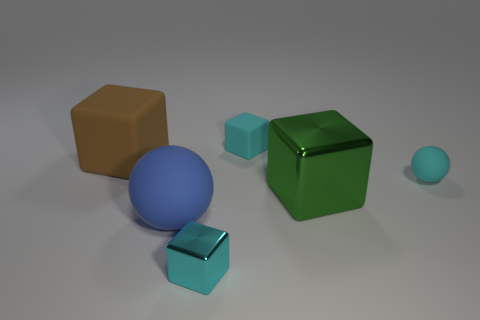How big is the blue matte object?
Offer a very short reply. Large. What shape is the big brown object?
Give a very brief answer. Cube. There is a green metal object; is its shape the same as the small cyan matte object that is left of the cyan ball?
Keep it short and to the point. Yes. Does the large matte thing that is in front of the large green metallic cube have the same shape as the brown object?
Ensure brevity in your answer.  No. How many small cyan matte objects are both behind the brown matte cube and in front of the big brown matte object?
Your response must be concise. 0. Is the number of cyan rubber blocks that are on the left side of the large blue sphere the same as the number of red metallic balls?
Provide a succinct answer. Yes. There is a sphere to the right of the small metal object; is its color the same as the tiny block behind the cyan shiny block?
Ensure brevity in your answer.  Yes. There is a thing that is in front of the green shiny block and on the right side of the big ball; what material is it made of?
Provide a succinct answer. Metal. What color is the big sphere?
Your answer should be compact. Blue. How many other things are there of the same shape as the big metal thing?
Your response must be concise. 3. 